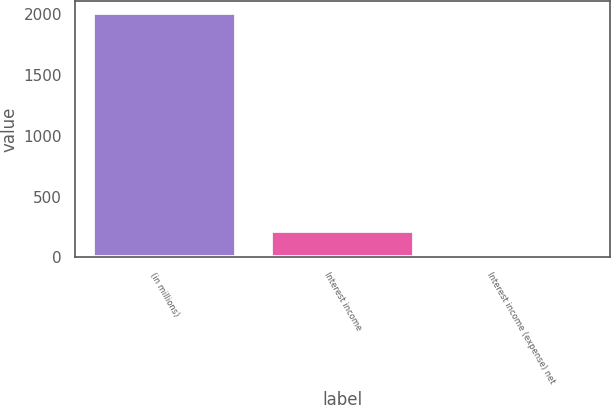<chart> <loc_0><loc_0><loc_500><loc_500><bar_chart><fcel>(in millions)<fcel>Interest income<fcel>Interest income (expense) net<nl><fcel>2012<fcel>218.03<fcel>18.7<nl></chart> 